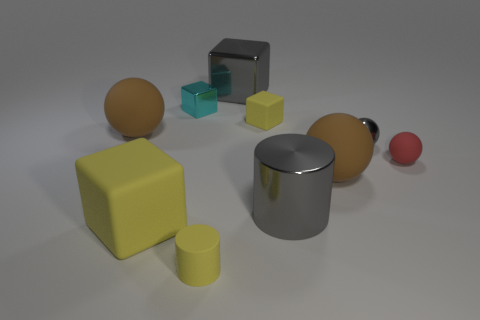Subtract all gray metallic spheres. How many spheres are left? 3 Subtract all green cylinders. How many brown spheres are left? 2 Subtract 2 spheres. How many spheres are left? 2 Subtract all gray blocks. How many blocks are left? 3 Subtract all red cubes. Subtract all red balls. How many cubes are left? 4 Subtract all cubes. How many objects are left? 6 Subtract all large metallic things. Subtract all big yellow rubber things. How many objects are left? 7 Add 4 small red objects. How many small red objects are left? 5 Add 5 large yellow rubber objects. How many large yellow rubber objects exist? 6 Subtract 1 brown spheres. How many objects are left? 9 